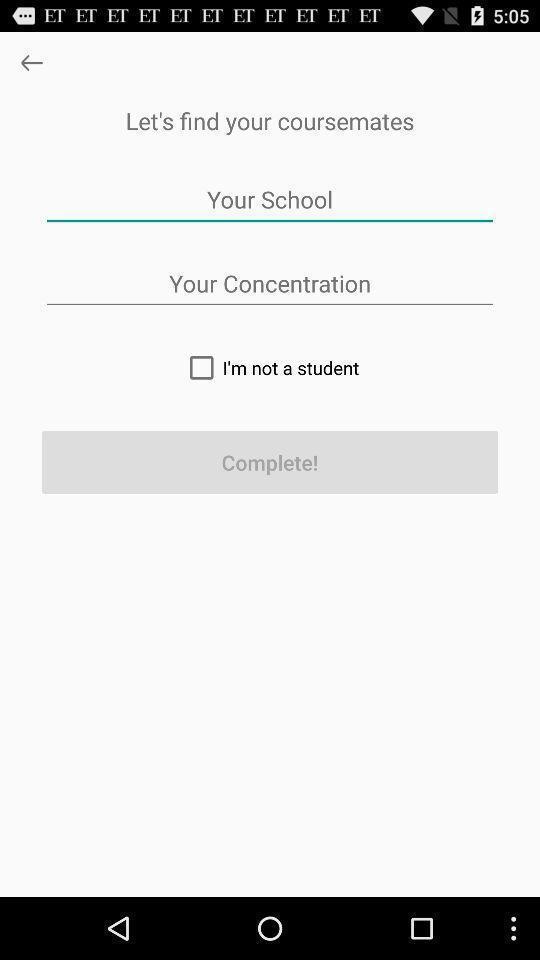Tell me about the visual elements in this screen capture. Welcome page of a learning app. 